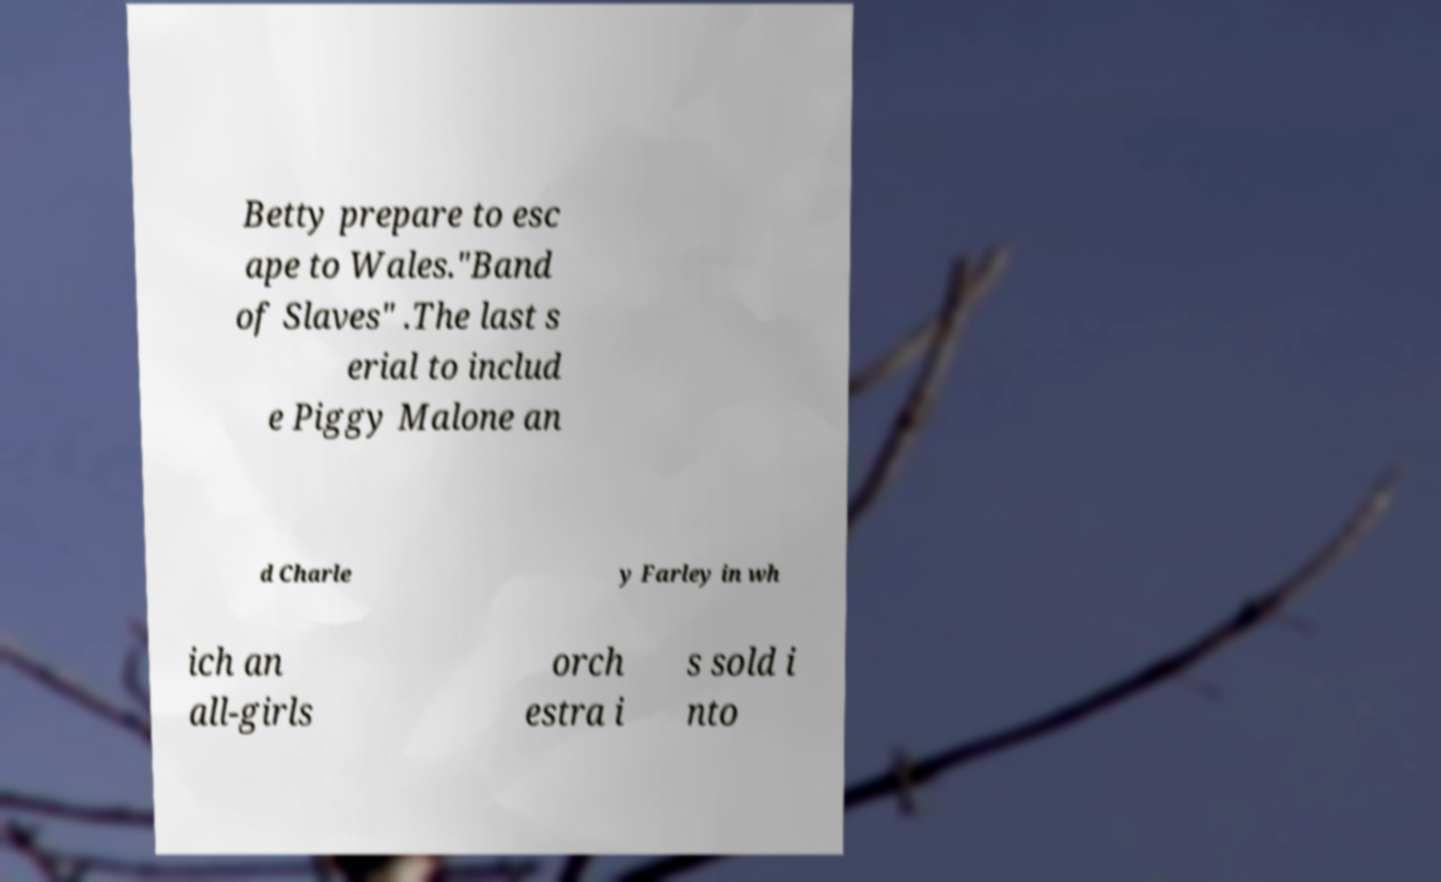Can you accurately transcribe the text from the provided image for me? Betty prepare to esc ape to Wales."Band of Slaves" .The last s erial to includ e Piggy Malone an d Charle y Farley in wh ich an all-girls orch estra i s sold i nto 